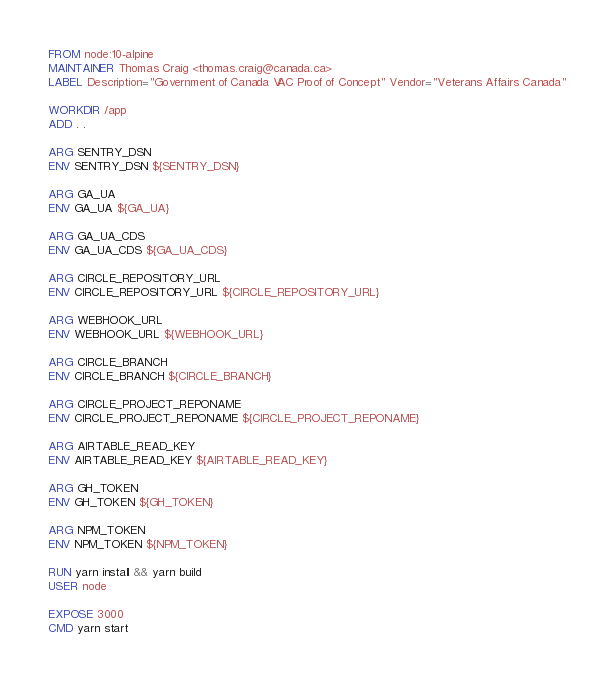<code> <loc_0><loc_0><loc_500><loc_500><_Dockerfile_>FROM node:10-alpine
MAINTAINER Thomas Craig <thomas.craig@canada.ca>
LABEL Description="Government of Canada VAC Proof of Concept" Vendor="Veterans Affairs Canada"

WORKDIR /app
ADD . .

ARG SENTRY_DSN
ENV SENTRY_DSN ${SENTRY_DSN}

ARG GA_UA
ENV GA_UA ${GA_UA}

ARG GA_UA_CDS
ENV GA_UA_CDS ${GA_UA_CDS}

ARG CIRCLE_REPOSITORY_URL
ENV CIRCLE_REPOSITORY_URL ${CIRCLE_REPOSITORY_URL}

ARG WEBHOOK_URL
ENV WEBHOOK_URL ${WEBHOOK_URL}

ARG CIRCLE_BRANCH
ENV CIRCLE_BRANCH ${CIRCLE_BRANCH}

ARG CIRCLE_PROJECT_REPONAME
ENV CIRCLE_PROJECT_REPONAME ${CIRCLE_PROJECT_REPONAME}

ARG AIRTABLE_READ_KEY
ENV AIRTABLE_READ_KEY ${AIRTABLE_READ_KEY}

ARG GH_TOKEN
ENV GH_TOKEN ${GH_TOKEN}

ARG NPM_TOKEN
ENV NPM_TOKEN ${NPM_TOKEN}

RUN yarn install && yarn build
USER node

EXPOSE 3000
CMD yarn start
</code> 